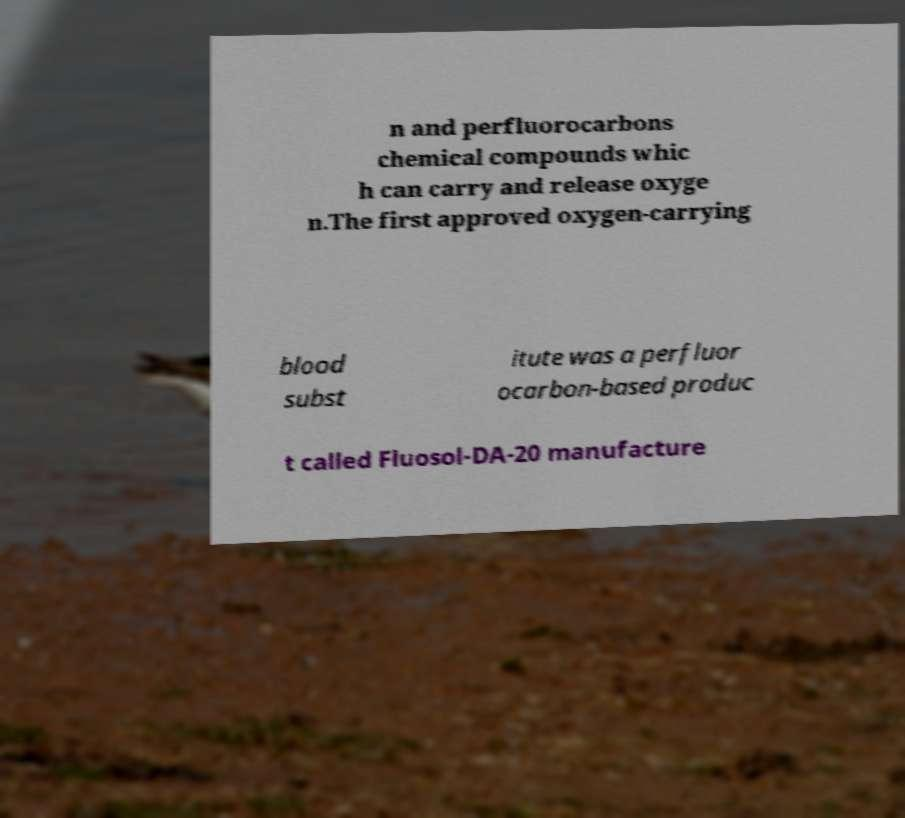Can you read and provide the text displayed in the image?This photo seems to have some interesting text. Can you extract and type it out for me? n and perfluorocarbons chemical compounds whic h can carry and release oxyge n.The first approved oxygen-carrying blood subst itute was a perfluor ocarbon-based produc t called Fluosol-DA-20 manufacture 